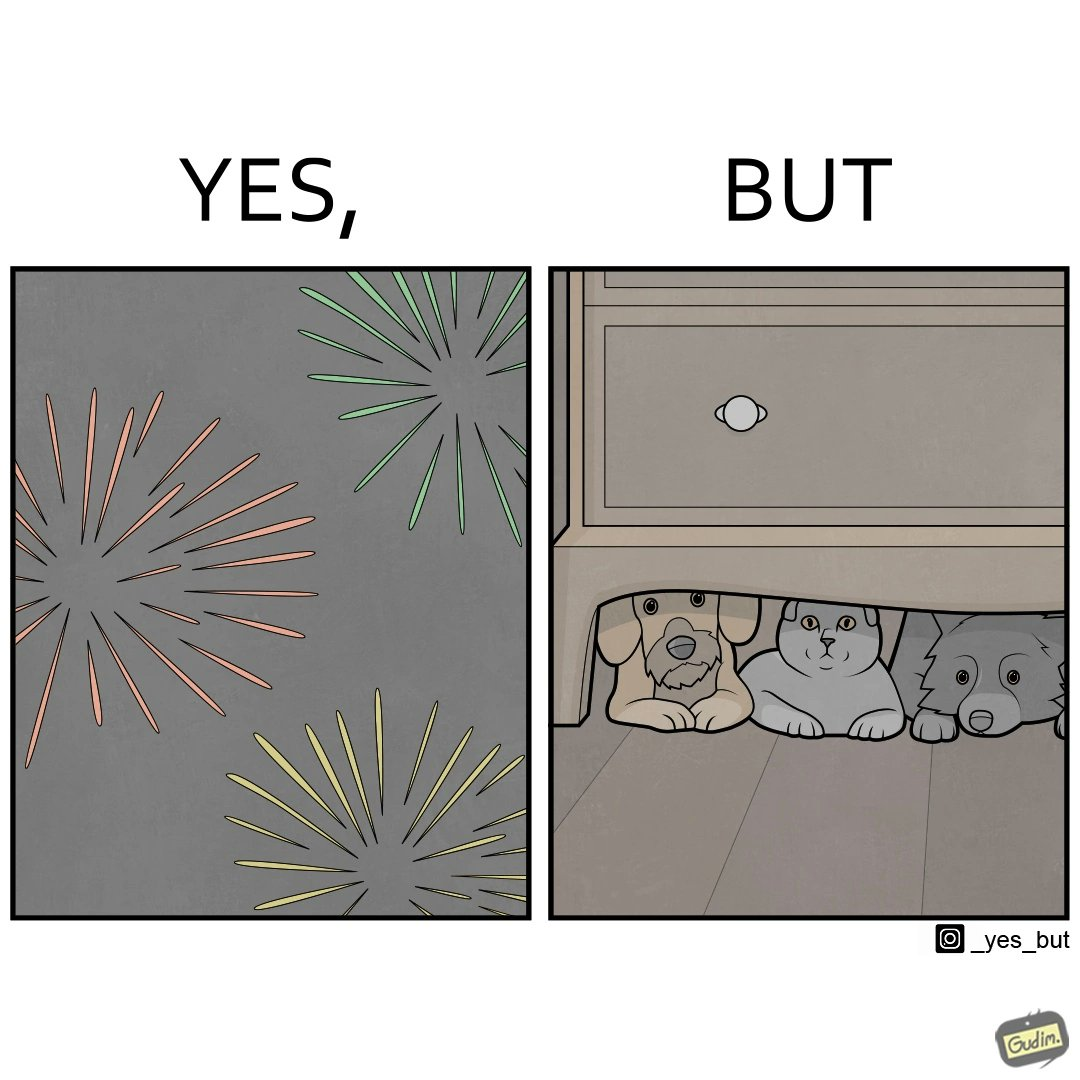Describe the contrast between the left and right parts of this image. In the left part of the image: The image shows colorful firecrackers going off in the sky. In the right part of the image: The image shows two dogs and a cat hiding under furniture. 